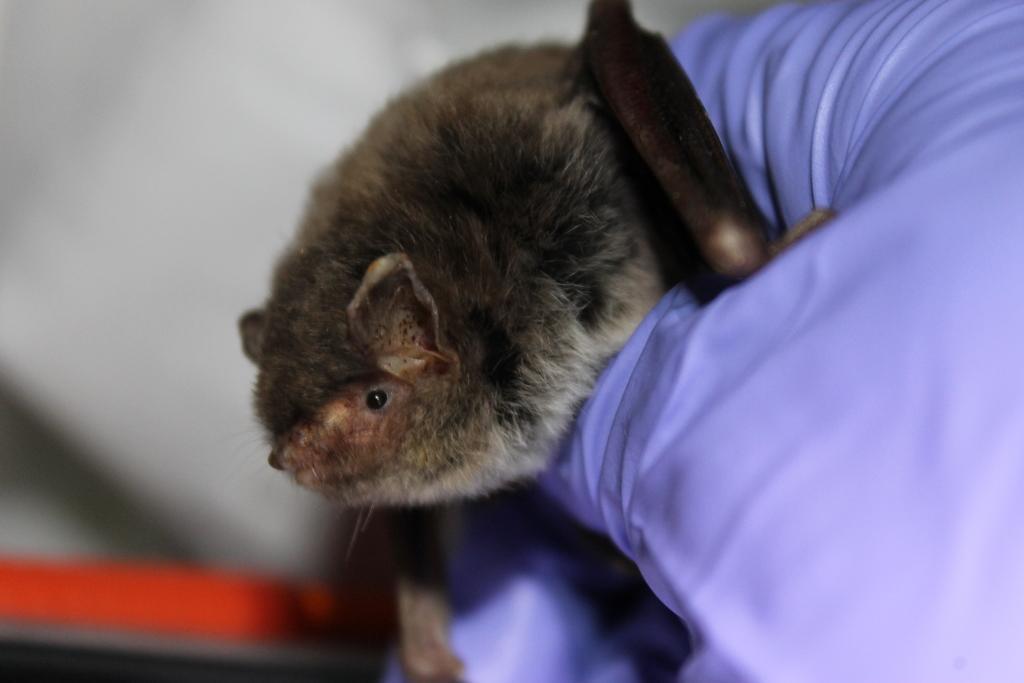Could you give a brief overview of what you see in this image? In this picture there is an evening bat in the image, on a pillow. 